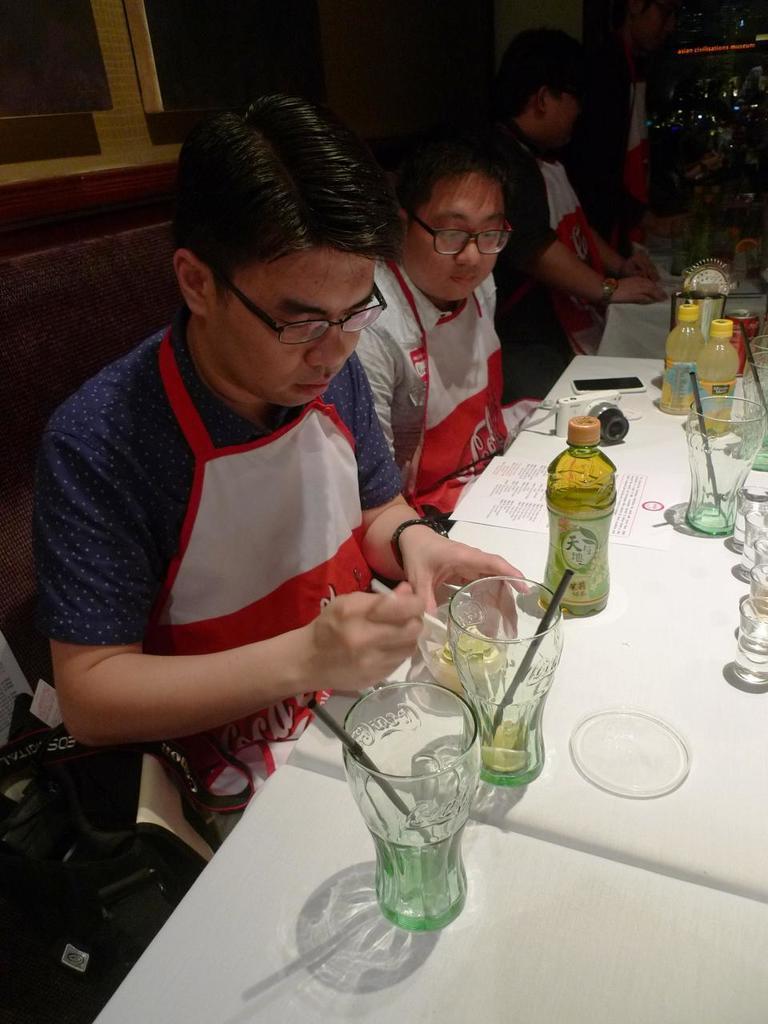Could you give a brief overview of what you see in this image? There are few people sitting on the chair at the table. On the table we can see glasses,bottles,mobile phone and a paper. 